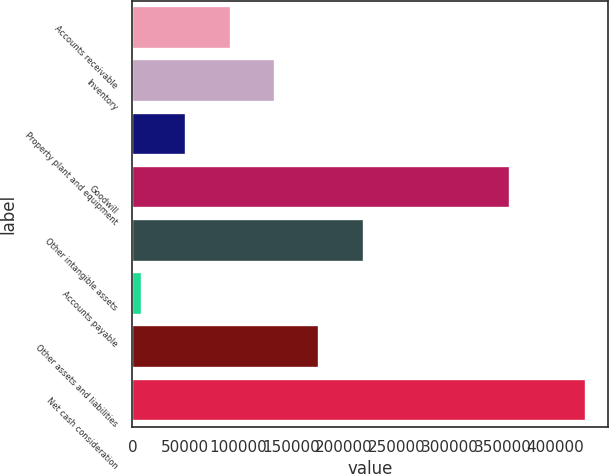Convert chart to OTSL. <chart><loc_0><loc_0><loc_500><loc_500><bar_chart><fcel>Accounts receivable<fcel>Inventory<fcel>Property plant and equipment<fcel>Goodwill<fcel>Other intangible assets<fcel>Accounts payable<fcel>Other assets and liabilities<fcel>Net cash consideration<nl><fcel>92762<fcel>134735<fcel>50789<fcel>356967<fcel>218681<fcel>8816<fcel>176708<fcel>428546<nl></chart> 